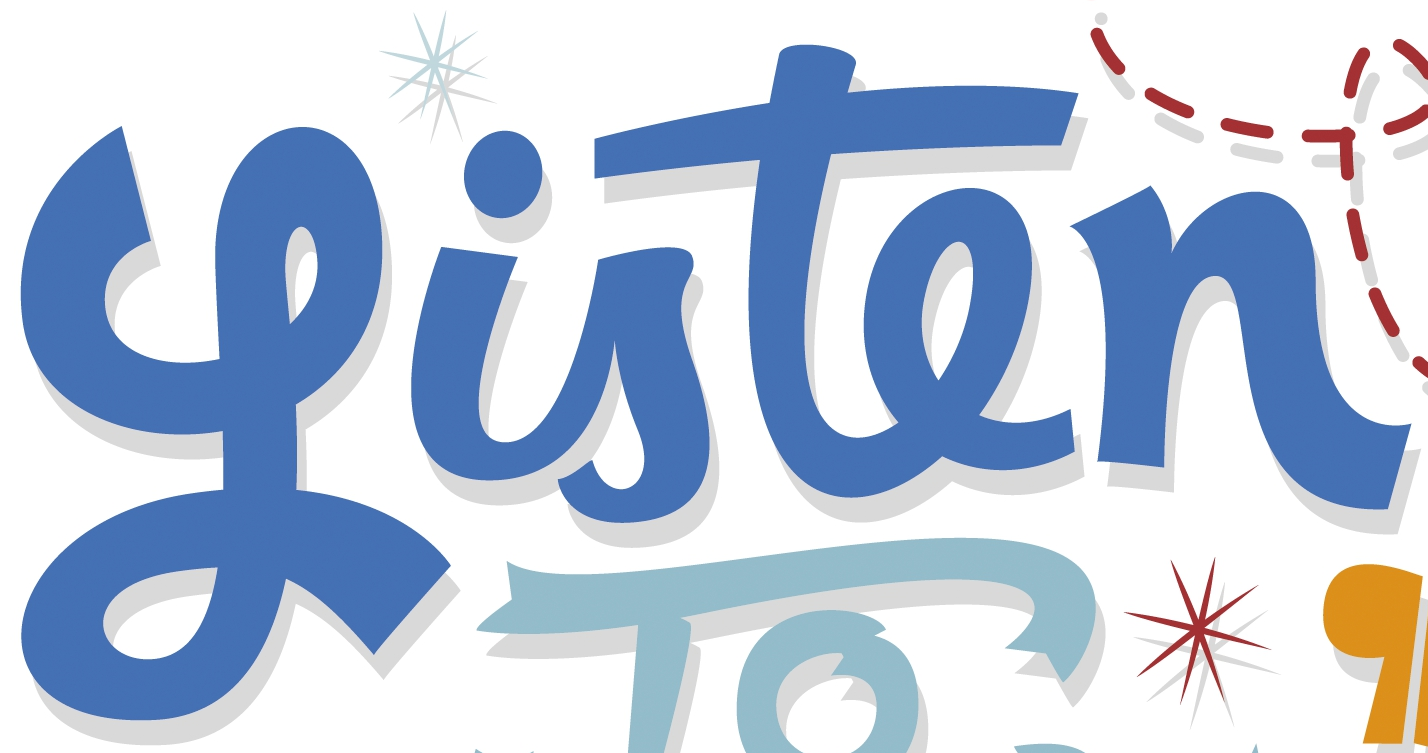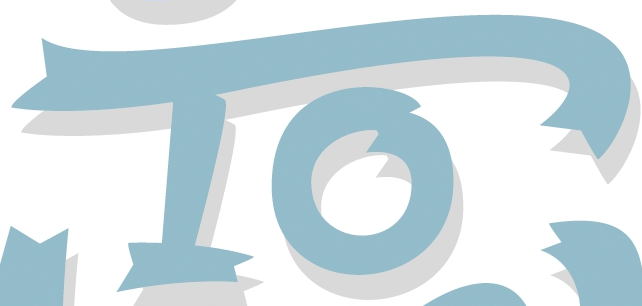What text is displayed in these images sequentially, separated by a semicolon? Listen; To 